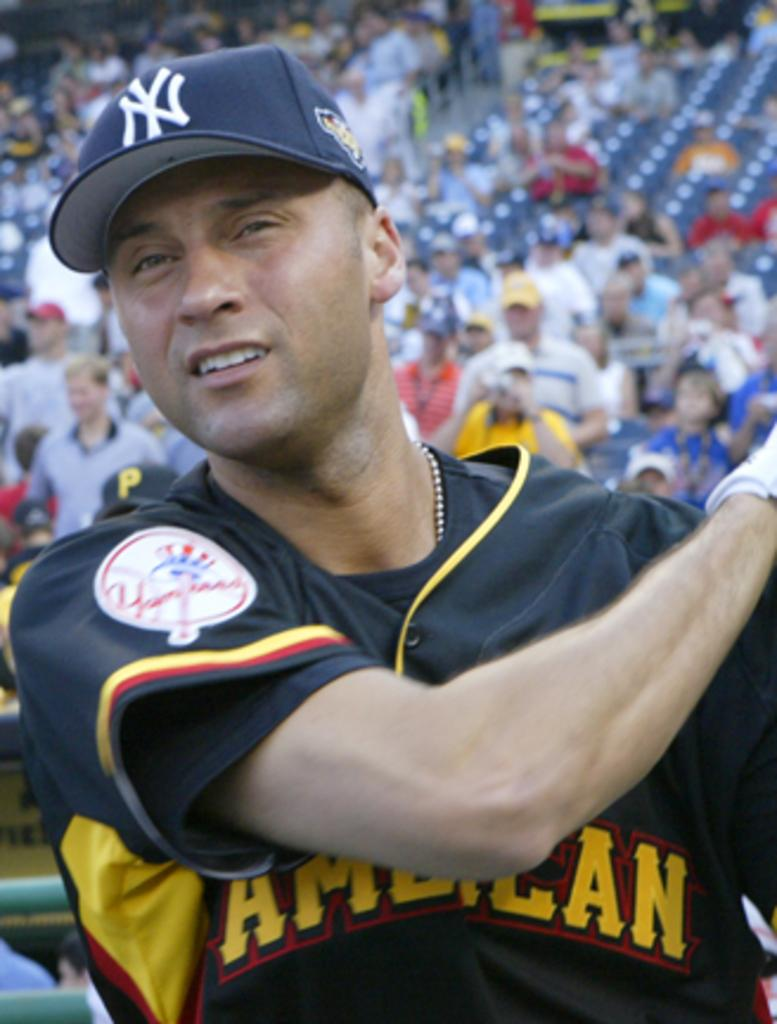<image>
Provide a brief description of the given image. The Yankees player stands in front of a large crowd. 